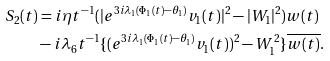<formula> <loc_0><loc_0><loc_500><loc_500>S _ { 2 } ( t ) & = i \eta t ^ { - 1 } ( | e ^ { 3 i \lambda _ { 1 } ( \Phi _ { 1 } ( t ) - \theta _ { 1 } ) } v _ { 1 } ( t ) | ^ { 2 } - | W _ { 1 } | ^ { 2 } ) w ( t ) \\ & - i \lambda _ { 6 } t ^ { - 1 } \{ ( e ^ { 3 i \lambda _ { 1 } ( \Phi _ { 1 } ( t ) - \theta _ { 1 } ) } v _ { 1 } ( t ) ) ^ { 2 } - W _ { 1 } ^ { 2 } \} \overline { w ( t ) } .</formula> 